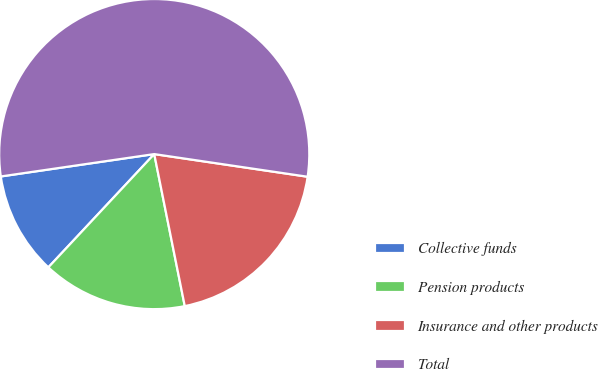Convert chart to OTSL. <chart><loc_0><loc_0><loc_500><loc_500><pie_chart><fcel>Collective funds<fcel>Pension products<fcel>Insurance and other products<fcel>Total<nl><fcel>10.73%<fcel>15.12%<fcel>19.51%<fcel>54.64%<nl></chart> 